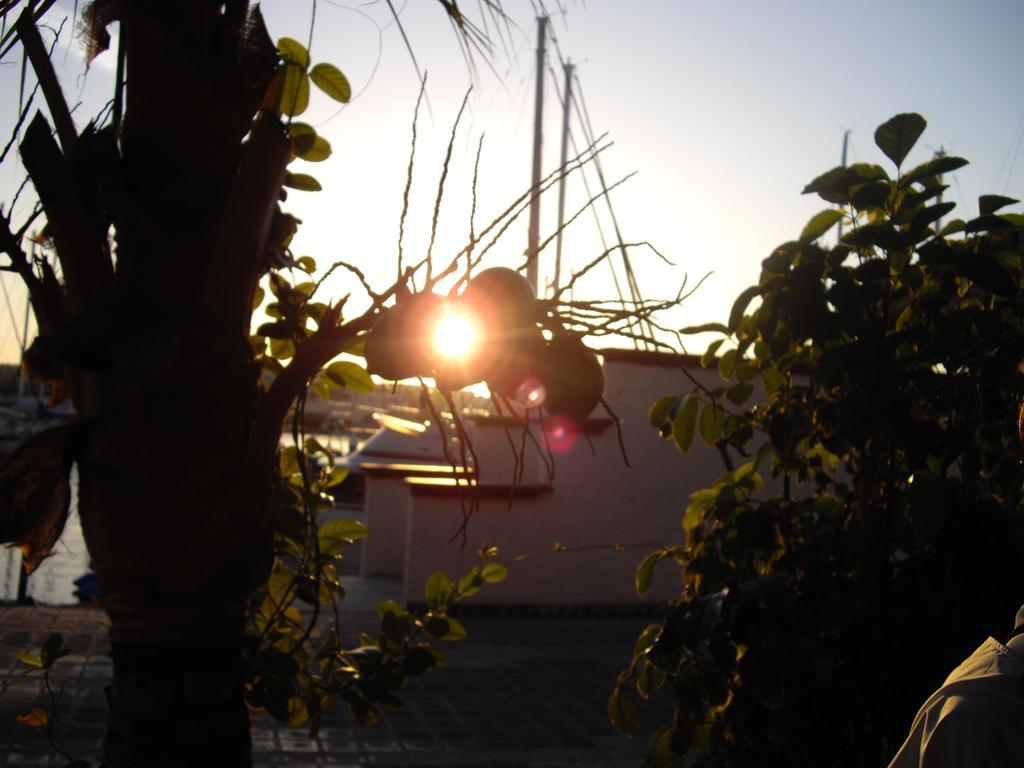Can you describe this image briefly? In this image, we can see two trees. There is a building and sun in the middle of the image. There is a sky at the top of the image. 